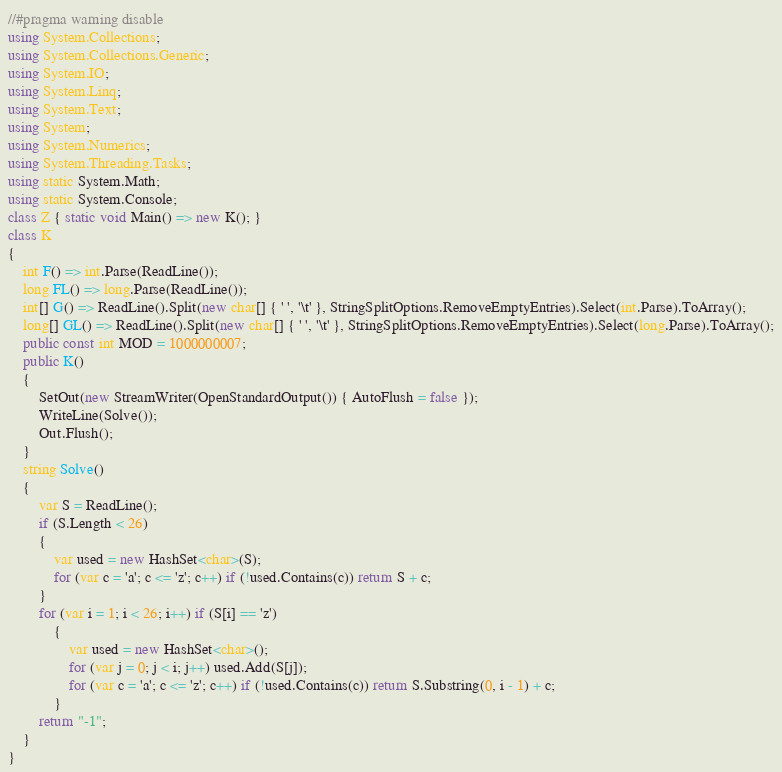Convert code to text. <code><loc_0><loc_0><loc_500><loc_500><_C#_>//#pragma warning disable
using System.Collections;
using System.Collections.Generic;
using System.IO;
using System.Linq;
using System.Text;
using System;
using System.Numerics;
using System.Threading.Tasks;
using static System.Math;
using static System.Console;
class Z { static void Main() => new K(); }
class K
{
	int F() => int.Parse(ReadLine());
	long FL() => long.Parse(ReadLine());
	int[] G() => ReadLine().Split(new char[] { ' ', '\t' }, StringSplitOptions.RemoveEmptyEntries).Select(int.Parse).ToArray();
	long[] GL() => ReadLine().Split(new char[] { ' ', '\t' }, StringSplitOptions.RemoveEmptyEntries).Select(long.Parse).ToArray();
	public const int MOD = 1000000007;
	public K()
	{
		SetOut(new StreamWriter(OpenStandardOutput()) { AutoFlush = false });
		WriteLine(Solve());
		Out.Flush();
	}
	string Solve()
	{
		var S = ReadLine();
		if (S.Length < 26)
		{
			var used = new HashSet<char>(S);
			for (var c = 'a'; c <= 'z'; c++) if (!used.Contains(c)) return S + c;
		}
		for (var i = 1; i < 26; i++) if (S[i] == 'z')
			{
				var used = new HashSet<char>();
				for (var j = 0; j < i; j++) used.Add(S[j]);
				for (var c = 'a'; c <= 'z'; c++) if (!used.Contains(c)) return S.Substring(0, i - 1) + c;
			}
		return "-1";
	}
}
</code> 